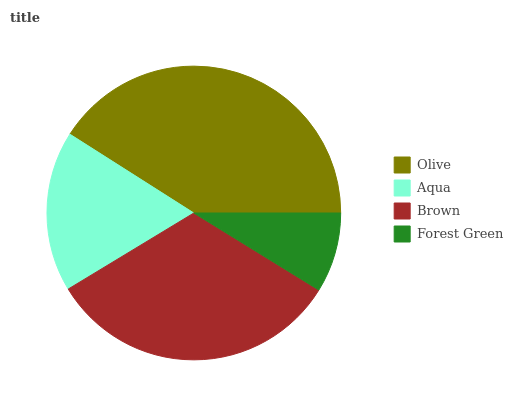Is Forest Green the minimum?
Answer yes or no. Yes. Is Olive the maximum?
Answer yes or no. Yes. Is Aqua the minimum?
Answer yes or no. No. Is Aqua the maximum?
Answer yes or no. No. Is Olive greater than Aqua?
Answer yes or no. Yes. Is Aqua less than Olive?
Answer yes or no. Yes. Is Aqua greater than Olive?
Answer yes or no. No. Is Olive less than Aqua?
Answer yes or no. No. Is Brown the high median?
Answer yes or no. Yes. Is Aqua the low median?
Answer yes or no. Yes. Is Forest Green the high median?
Answer yes or no. No. Is Brown the low median?
Answer yes or no. No. 